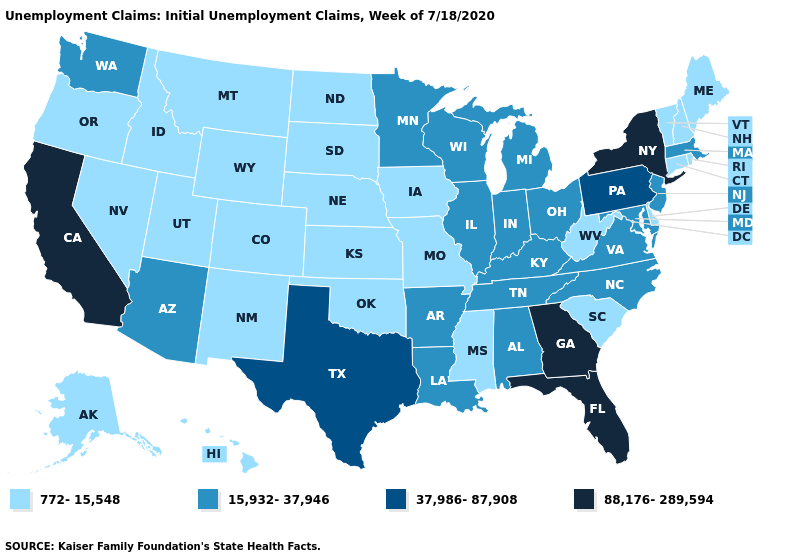What is the value of California?
Give a very brief answer. 88,176-289,594. Does Iowa have the same value as Alabama?
Concise answer only. No. Does the first symbol in the legend represent the smallest category?
Quick response, please. Yes. Does Wisconsin have a lower value than Nevada?
Concise answer only. No. Which states have the highest value in the USA?
Answer briefly. California, Florida, Georgia, New York. Name the states that have a value in the range 15,932-37,946?
Short answer required. Alabama, Arizona, Arkansas, Illinois, Indiana, Kentucky, Louisiana, Maryland, Massachusetts, Michigan, Minnesota, New Jersey, North Carolina, Ohio, Tennessee, Virginia, Washington, Wisconsin. What is the highest value in the USA?
Be succinct. 88,176-289,594. Among the states that border Ohio , does West Virginia have the lowest value?
Quick response, please. Yes. Name the states that have a value in the range 88,176-289,594?
Give a very brief answer. California, Florida, Georgia, New York. What is the highest value in states that border New Jersey?
Write a very short answer. 88,176-289,594. What is the value of North Carolina?
Give a very brief answer. 15,932-37,946. Does Vermont have the highest value in the USA?
Be succinct. No. Among the states that border Kentucky , which have the highest value?
Answer briefly. Illinois, Indiana, Ohio, Tennessee, Virginia. Name the states that have a value in the range 772-15,548?
Quick response, please. Alaska, Colorado, Connecticut, Delaware, Hawaii, Idaho, Iowa, Kansas, Maine, Mississippi, Missouri, Montana, Nebraska, Nevada, New Hampshire, New Mexico, North Dakota, Oklahoma, Oregon, Rhode Island, South Carolina, South Dakota, Utah, Vermont, West Virginia, Wyoming. Among the states that border Colorado , does Utah have the highest value?
Give a very brief answer. No. 